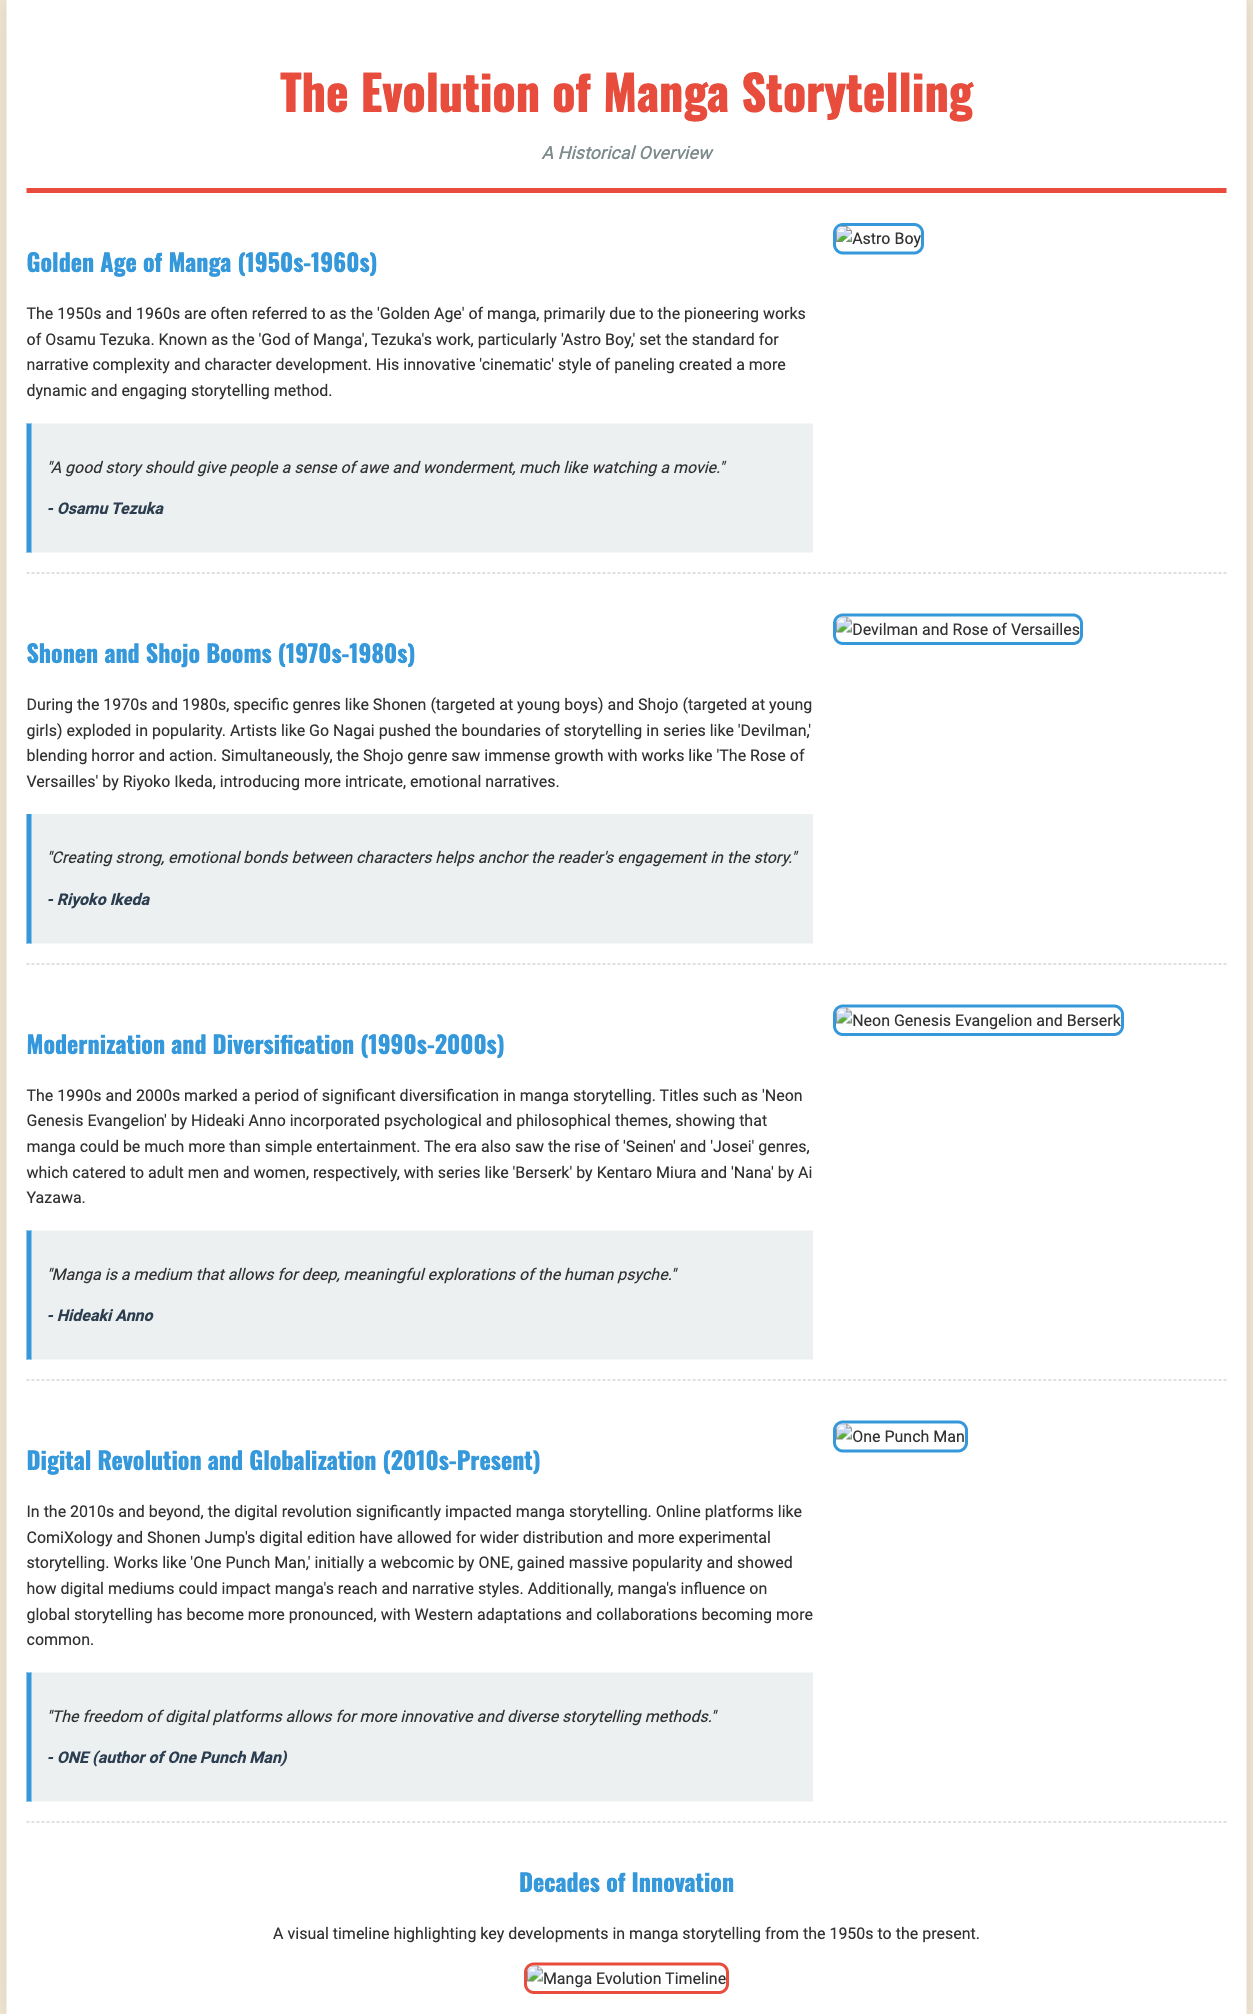What years are considered the Golden Age of Manga? The document states that the Golden Age of Manga is from the 1950s to the 1960s.
Answer: 1950s-1960s Who is known as the 'God of Manga'? The document identifies Osamu Tezuka as the 'God of Manga'.
Answer: Osamu Tezuka What genre exploded in popularity during the 1970s and 1980s? The document mentions that genres like Shonen and Shojo exploded in popularity during this time.
Answer: Shonen and Shojo Which manga introduced psychological themes in the 1990s? The document refers to 'Neon Genesis Evangelion' as incorporating psychological themes in the 1990s.
Answer: Neon Genesis Evangelion What digital platform is mentioned for wider distribution of manga? The document highlights ComiXology as a digital platform for wider distribution.
Answer: ComiXology What is the main visual highlighted in the infographic section? The infographic section discusses a visual timeline highlighting key developments in manga storytelling.
Answer: Key developments in manga storytelling What quote is attributed to Riyoko Ikeda? The document includes a quote from Riyoko Ikeda about creating strong emotional bonds between characters.
Answer: "Creating strong, emotional bonds between characters helps anchor the reader's engagement in the story." What year range marks the era of Modernization and Diversification in manga? According to the document, the period of Modernization and Diversification in manga is from the 1990s to the 2000s.
Answer: 1990s-2000s 